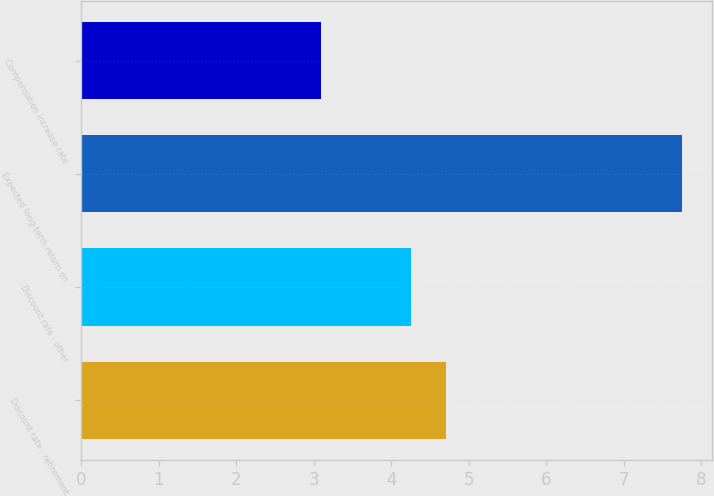<chart> <loc_0><loc_0><loc_500><loc_500><bar_chart><fcel>Discount rate - retirement<fcel>Discount rate - other<fcel>Expected long-term return on<fcel>Compensation increase rate<nl><fcel>4.71<fcel>4.25<fcel>7.75<fcel>3.1<nl></chart> 